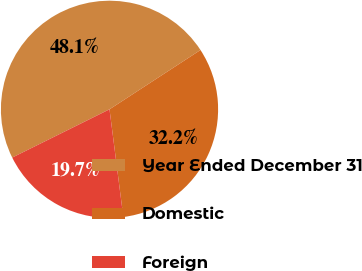Convert chart. <chart><loc_0><loc_0><loc_500><loc_500><pie_chart><fcel>Year Ended December 31<fcel>Domestic<fcel>Foreign<nl><fcel>48.13%<fcel>32.16%<fcel>19.7%<nl></chart> 